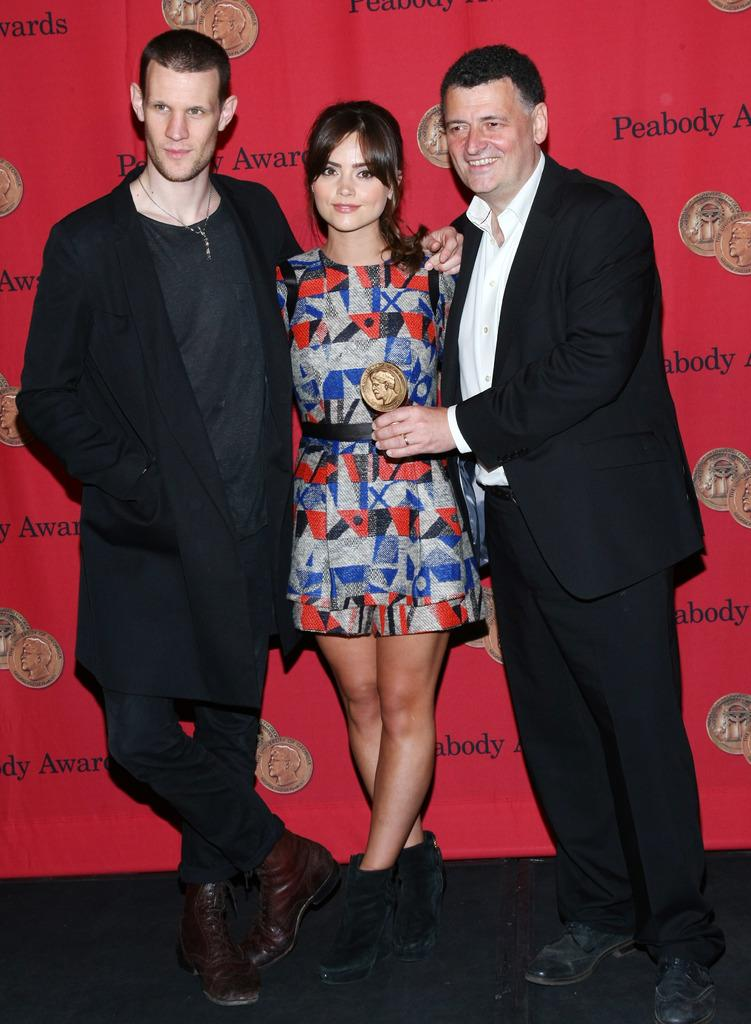How many people are in the image? There are three persons standing in the image. What is one of the persons holding? One person is holding an award. What can be seen in the background of the image? There is a banner with text and images in the background. What type of fuel is being used by the trains in the image? There are no trains present in the image, so it is not possible to determine what type of fuel they might be using. 